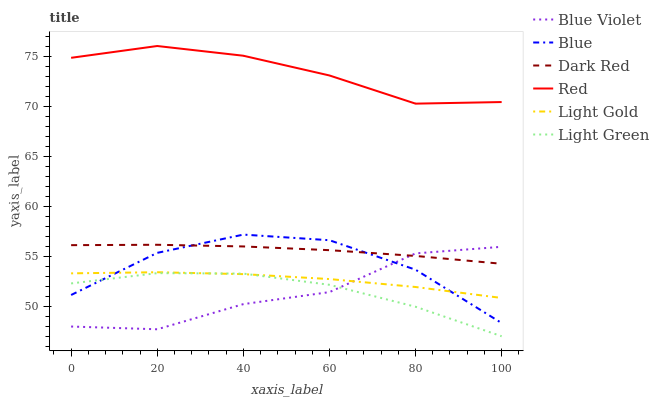Does Blue Violet have the minimum area under the curve?
Answer yes or no. Yes. Does Red have the maximum area under the curve?
Answer yes or no. Yes. Does Dark Red have the minimum area under the curve?
Answer yes or no. No. Does Dark Red have the maximum area under the curve?
Answer yes or no. No. Is Dark Red the smoothest?
Answer yes or no. Yes. Is Blue Violet the roughest?
Answer yes or no. Yes. Is Blue Violet the smoothest?
Answer yes or no. No. Is Dark Red the roughest?
Answer yes or no. No. Does Dark Red have the lowest value?
Answer yes or no. No. Does Dark Red have the highest value?
Answer yes or no. No. Is Light Gold less than Red?
Answer yes or no. Yes. Is Dark Red greater than Light Gold?
Answer yes or no. Yes. Does Light Gold intersect Red?
Answer yes or no. No. 